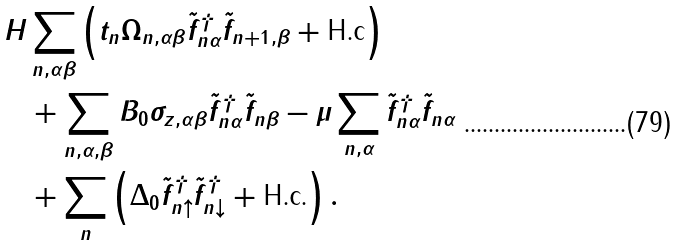Convert formula to latex. <formula><loc_0><loc_0><loc_500><loc_500>H & \sum _ { n , \alpha \beta } \left ( t _ { n } \Omega _ { n , \alpha \beta } \tilde { f } ^ { \dagger } _ { n \alpha } \tilde { f } _ { n + 1 , \beta } + \text {H.c} \right ) \\ & + \sum _ { n , \alpha , \beta } B _ { 0 } \sigma _ { z , \alpha \beta } \tilde { f } ^ { \dagger } _ { n \alpha } \tilde { f } _ { n \beta } - \mu \sum _ { n , \alpha } \tilde { f } ^ { \dagger } _ { n \alpha } \tilde { f } _ { n \alpha } \\ & + \sum _ { n } \left ( \Delta _ { 0 } \tilde { f } ^ { \dagger } _ { n \uparrow } \tilde { f } ^ { \dagger } _ { n \downarrow } + \text {H.c.} \right ) .</formula> 